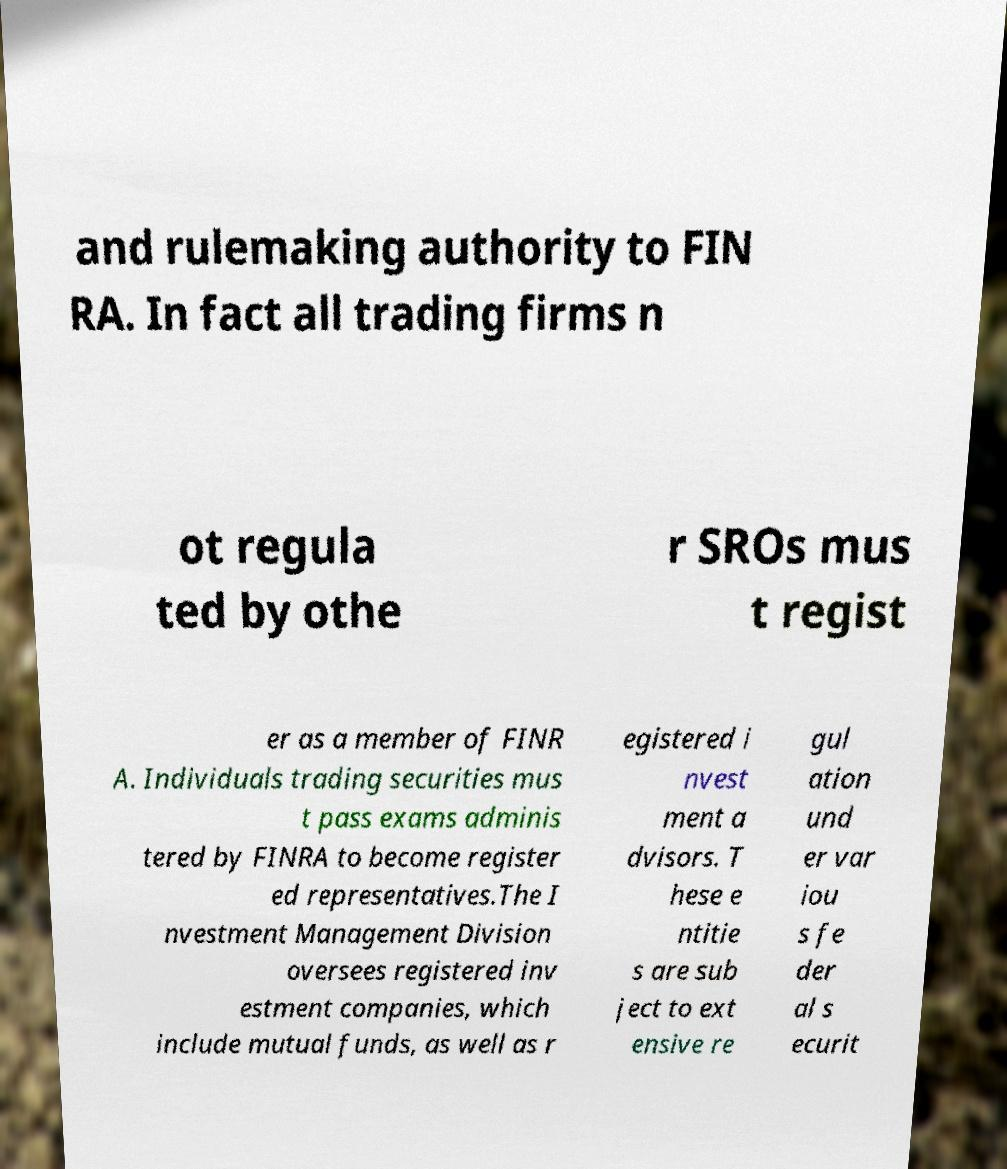Can you accurately transcribe the text from the provided image for me? and rulemaking authority to FIN RA. In fact all trading firms n ot regula ted by othe r SROs mus t regist er as a member of FINR A. Individuals trading securities mus t pass exams adminis tered by FINRA to become register ed representatives.The I nvestment Management Division oversees registered inv estment companies, which include mutual funds, as well as r egistered i nvest ment a dvisors. T hese e ntitie s are sub ject to ext ensive re gul ation und er var iou s fe der al s ecurit 